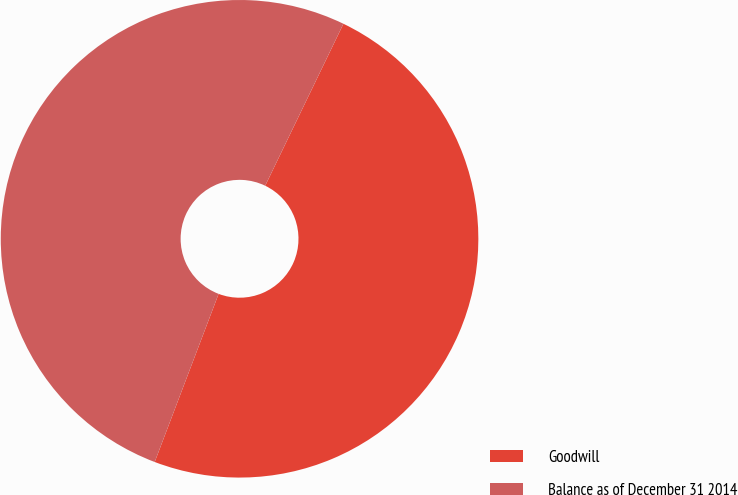Convert chart. <chart><loc_0><loc_0><loc_500><loc_500><pie_chart><fcel>Goodwill<fcel>Balance as of December 31 2014<nl><fcel>48.62%<fcel>51.38%<nl></chart> 